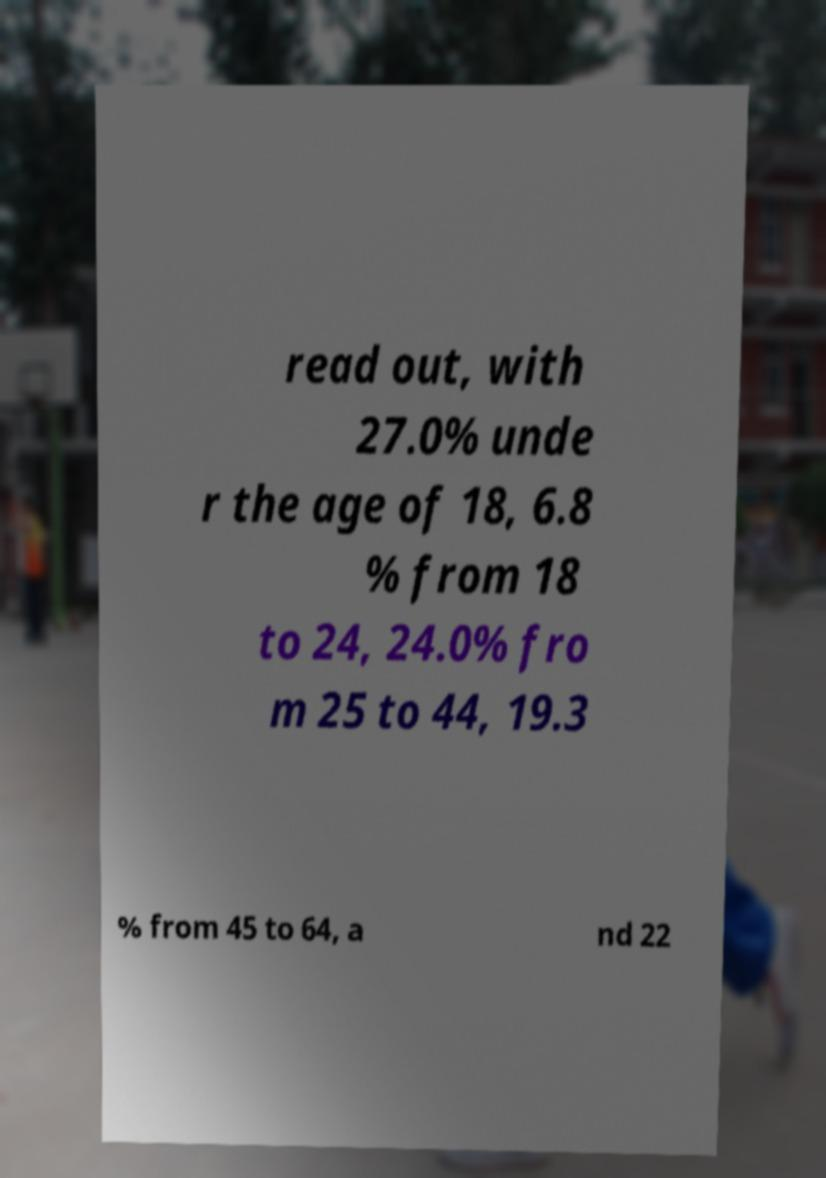What messages or text are displayed in this image? I need them in a readable, typed format. read out, with 27.0% unde r the age of 18, 6.8 % from 18 to 24, 24.0% fro m 25 to 44, 19.3 % from 45 to 64, a nd 22 